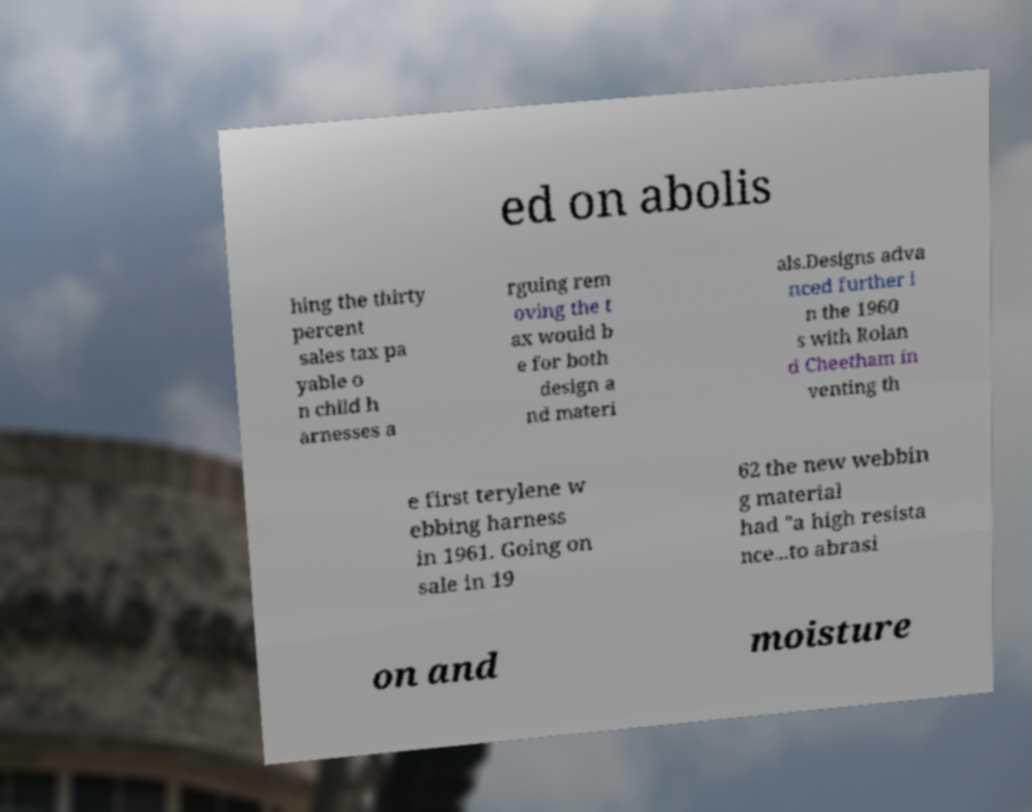For documentation purposes, I need the text within this image transcribed. Could you provide that? ed on abolis hing the thirty percent sales tax pa yable o n child h arnesses a rguing rem oving the t ax would b e for both design a nd materi als.Designs adva nced further i n the 1960 s with Rolan d Cheetham in venting th e first terylene w ebbing harness in 1961. Going on sale in 19 62 the new webbin g material had "a high resista nce...to abrasi on and moisture 